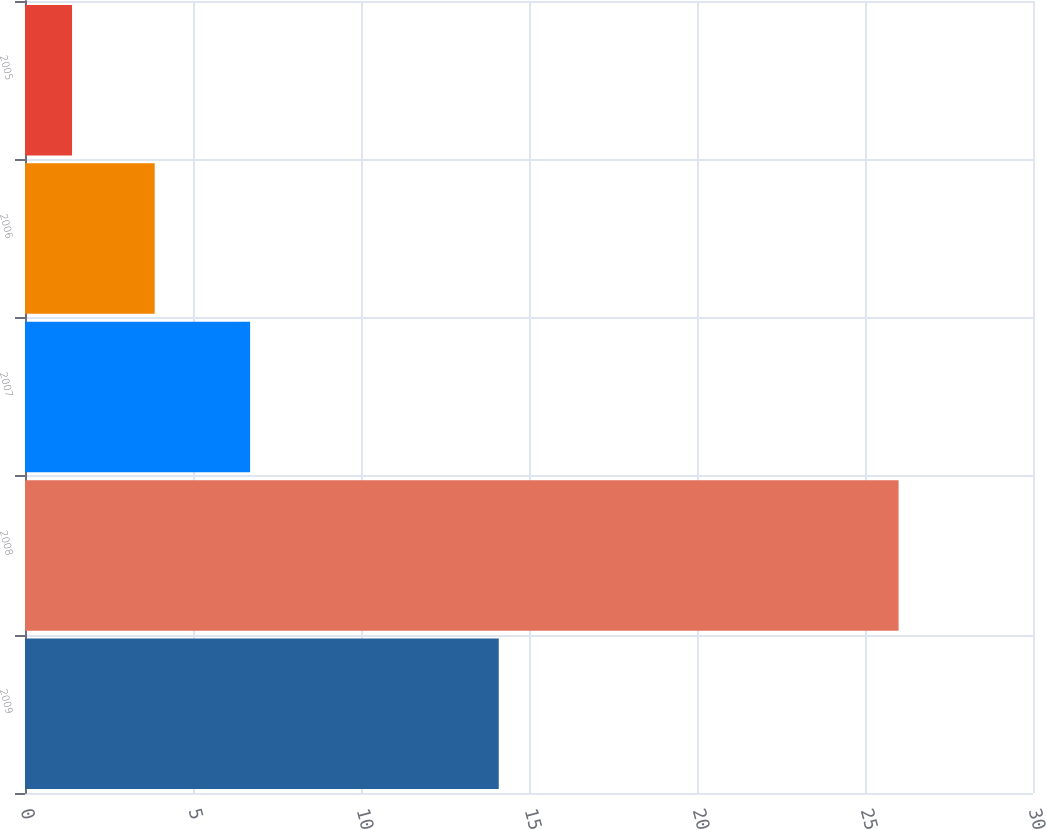Convert chart to OTSL. <chart><loc_0><loc_0><loc_500><loc_500><bar_chart><fcel>2009<fcel>2008<fcel>2007<fcel>2006<fcel>2005<nl><fcel>14.1<fcel>26<fcel>6.7<fcel>3.86<fcel>1.4<nl></chart> 